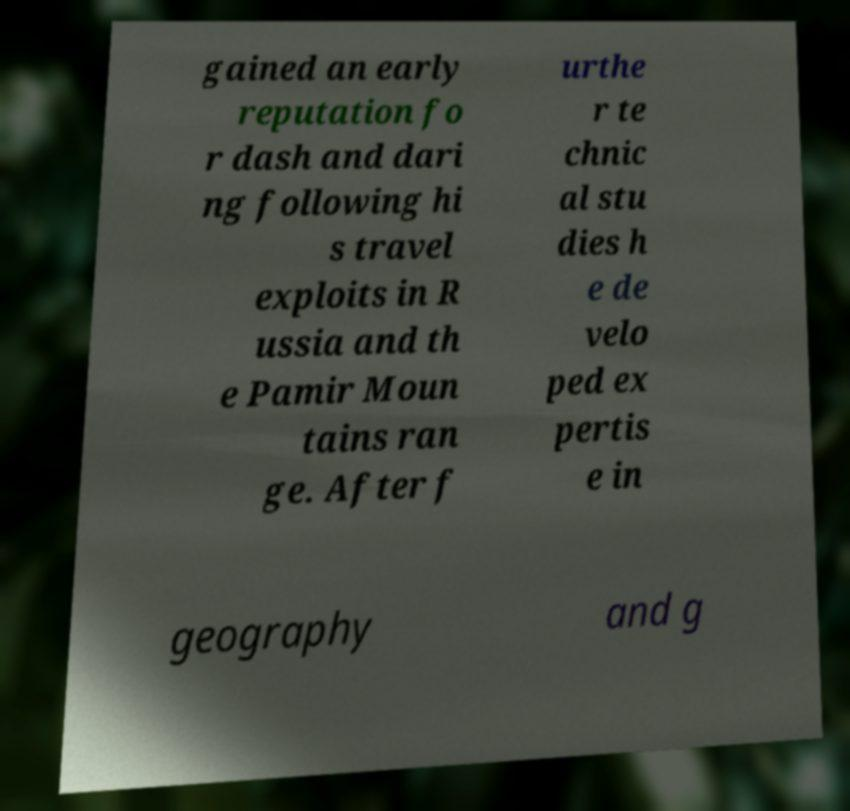For documentation purposes, I need the text within this image transcribed. Could you provide that? gained an early reputation fo r dash and dari ng following hi s travel exploits in R ussia and th e Pamir Moun tains ran ge. After f urthe r te chnic al stu dies h e de velo ped ex pertis e in geography and g 